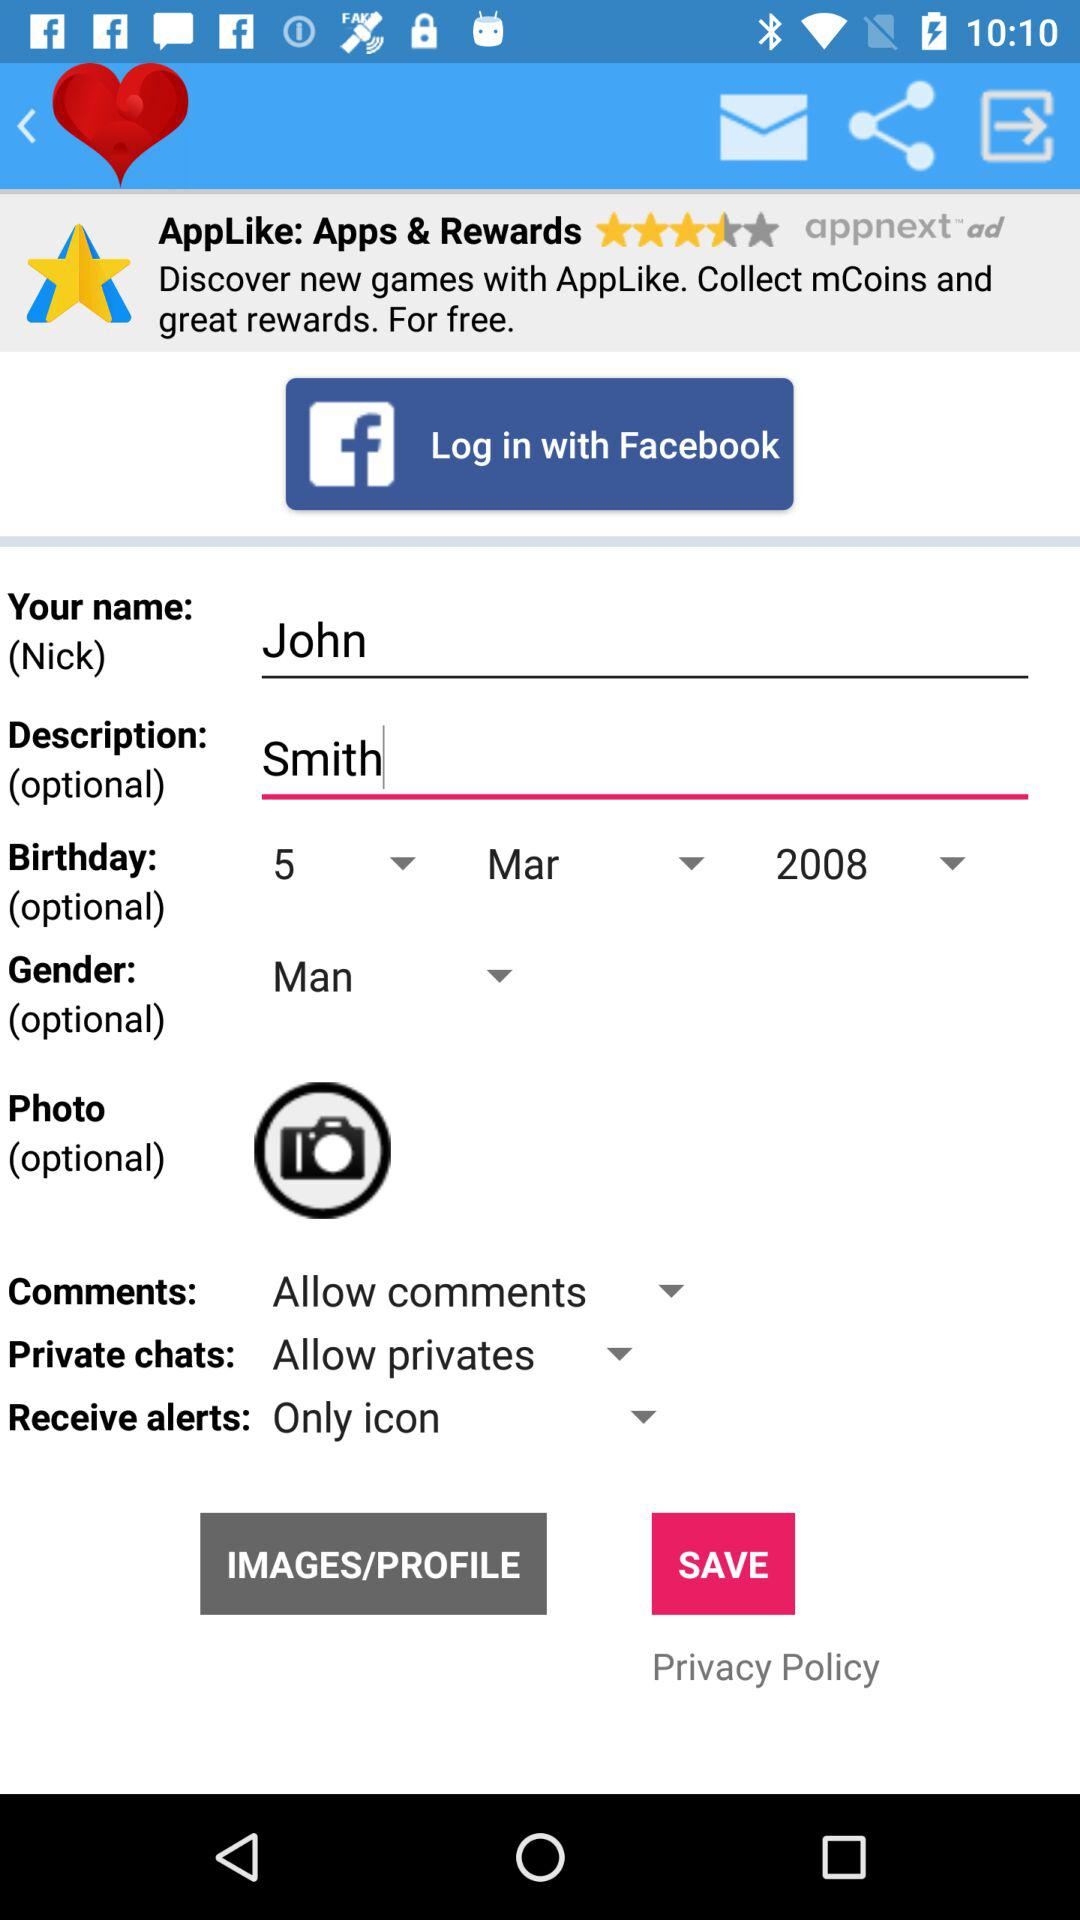What is the name? The name is John. 